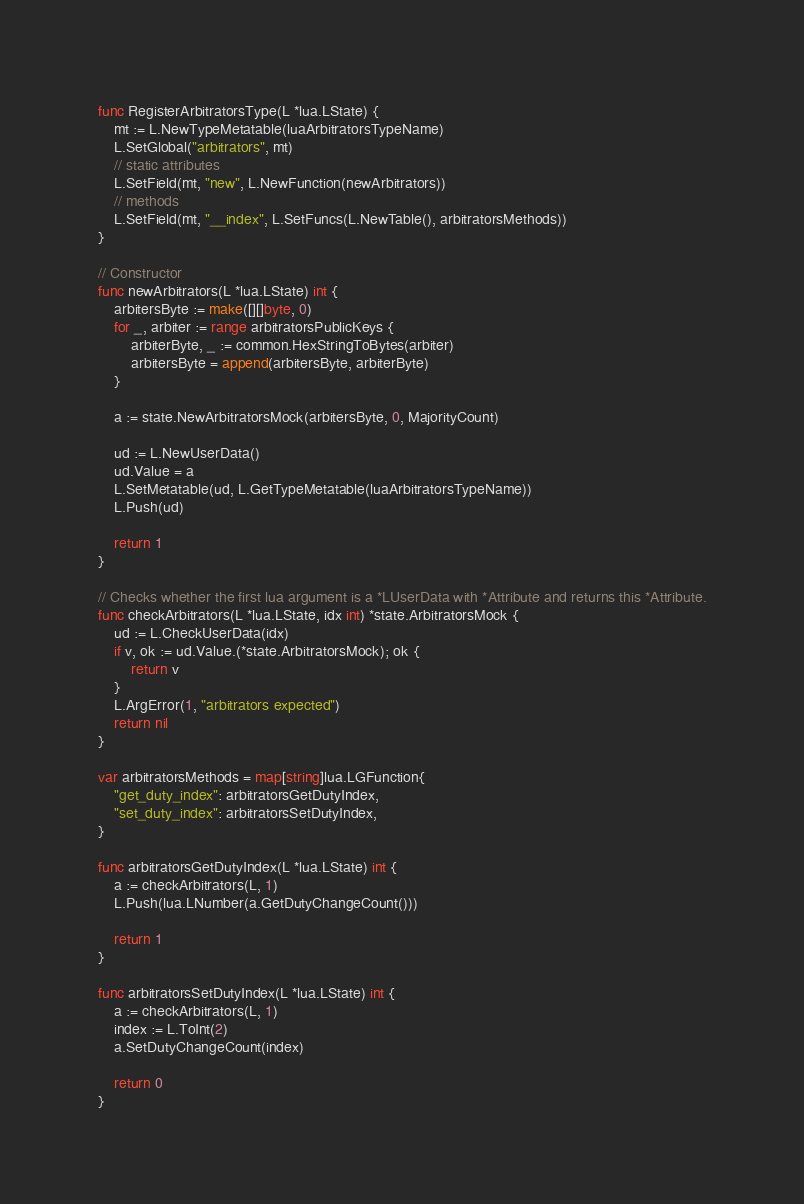<code> <loc_0><loc_0><loc_500><loc_500><_Go_>func RegisterArbitratorsType(L *lua.LState) {
	mt := L.NewTypeMetatable(luaArbitratorsTypeName)
	L.SetGlobal("arbitrators", mt)
	// static attributes
	L.SetField(mt, "new", L.NewFunction(newArbitrators))
	// methods
	L.SetField(mt, "__index", L.SetFuncs(L.NewTable(), arbitratorsMethods))
}

// Constructor
func newArbitrators(L *lua.LState) int {
	arbitersByte := make([][]byte, 0)
	for _, arbiter := range arbitratorsPublicKeys {
		arbiterByte, _ := common.HexStringToBytes(arbiter)
		arbitersByte = append(arbitersByte, arbiterByte)
	}

	a := state.NewArbitratorsMock(arbitersByte, 0, MajorityCount)

	ud := L.NewUserData()
	ud.Value = a
	L.SetMetatable(ud, L.GetTypeMetatable(luaArbitratorsTypeName))
	L.Push(ud)

	return 1
}

// Checks whether the first lua argument is a *LUserData with *Attribute and returns this *Attribute.
func checkArbitrators(L *lua.LState, idx int) *state.ArbitratorsMock {
	ud := L.CheckUserData(idx)
	if v, ok := ud.Value.(*state.ArbitratorsMock); ok {
		return v
	}
	L.ArgError(1, "arbitrators expected")
	return nil
}

var arbitratorsMethods = map[string]lua.LGFunction{
	"get_duty_index": arbitratorsGetDutyIndex,
	"set_duty_index": arbitratorsSetDutyIndex,
}

func arbitratorsGetDutyIndex(L *lua.LState) int {
	a := checkArbitrators(L, 1)
	L.Push(lua.LNumber(a.GetDutyChangeCount()))

	return 1
}

func arbitratorsSetDutyIndex(L *lua.LState) int {
	a := checkArbitrators(L, 1)
	index := L.ToInt(2)
	a.SetDutyChangeCount(index)

	return 0
}
</code> 